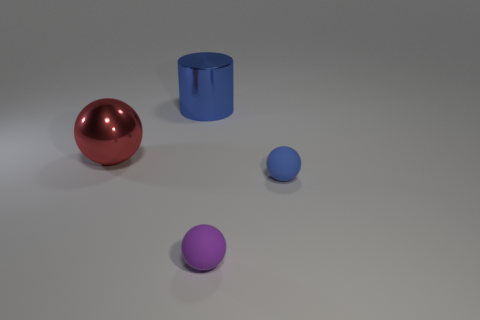Subtract all purple cylinders. Subtract all yellow blocks. How many cylinders are left? 1 Subtract all gray cubes. How many gray cylinders are left? 0 Add 4 large blues. How many small things exist? 0 Subtract all blue matte blocks. Subtract all large spheres. How many objects are left? 3 Add 4 small purple matte balls. How many small purple matte balls are left? 5 Add 4 big brown metallic cubes. How many big brown metallic cubes exist? 4 Add 2 small purple rubber things. How many objects exist? 6 Subtract all blue spheres. How many spheres are left? 2 Subtract all blue rubber balls. How many balls are left? 2 Subtract 0 yellow cylinders. How many objects are left? 4 